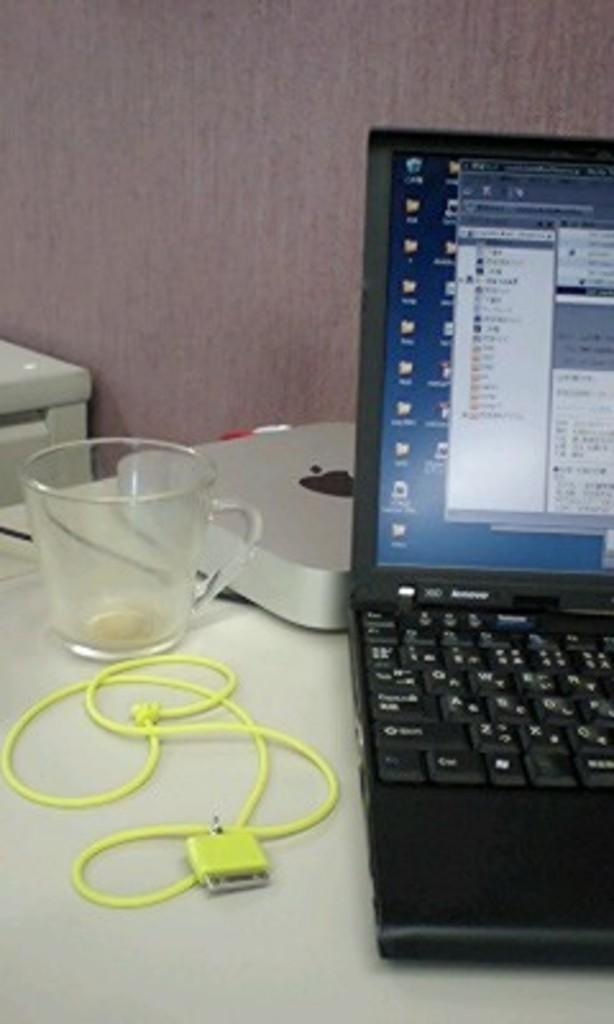What is on the table in the image? There is a cable, a cup, a chrome box, and a laptop on the table in the image. Can you describe the laptop in the image? The laptop is on the table in the image. What is visible in the background of the image? There is a wall and an object in the background of the image. What type of cakes are being served at the nation's celebration in the image? There is no nation's celebration or cakes present in the image. Can you tell me how many squirrels are visible in the image? There are no squirrels visible in the image. 